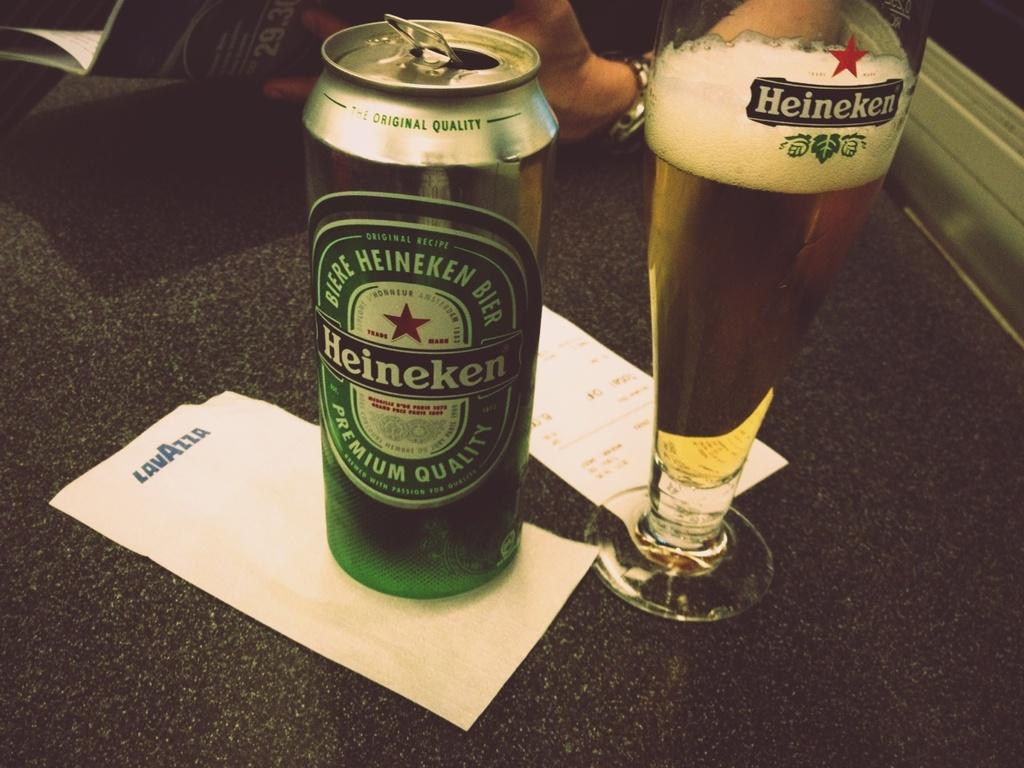What part of a person can be seen in the image? There is a person's hand in the image. What is the person holding in the image? The person is holding a book. What type of furniture is present in the image? There is a table in the image. What items can be seen on the table? There are papers, a bottle, and a glass with a drink on the table. What type of jeans is the person wearing in the image? There is no information about the person's clothing in the image, so we cannot determine if they are wearing jeans or any other type of clothing. What channel is the person watching on the television in the image? There is no television present in the image, so we cannot determine what channel the person might be watching. 